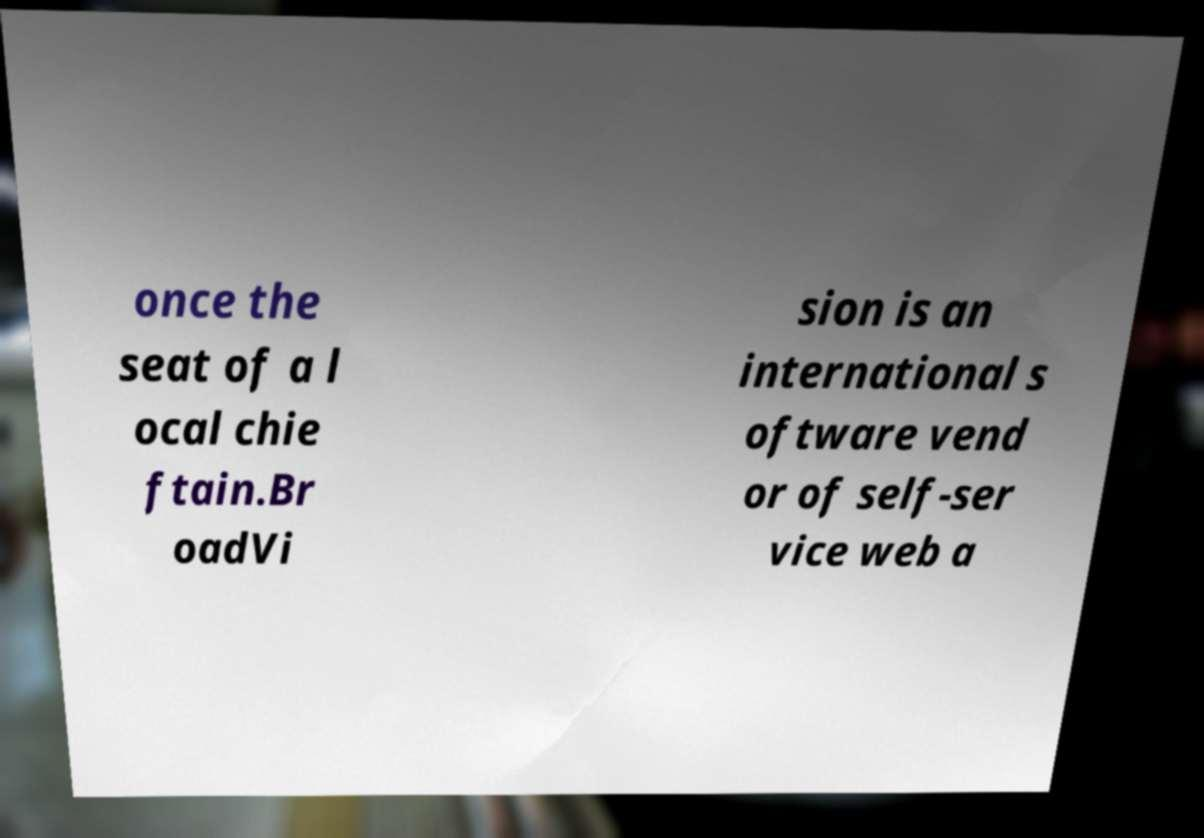Please read and relay the text visible in this image. What does it say? once the seat of a l ocal chie ftain.Br oadVi sion is an international s oftware vend or of self-ser vice web a 